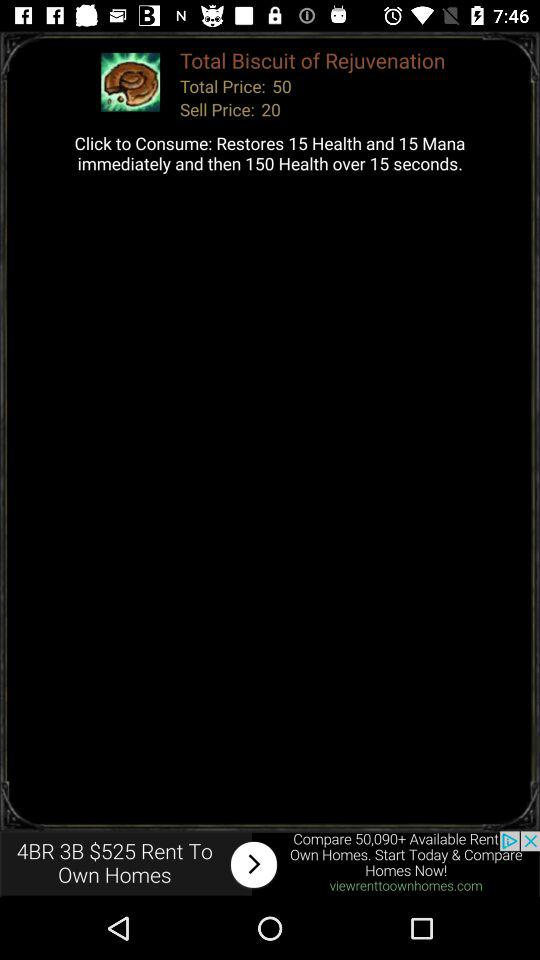How much health does the item restore immediately?
Answer the question using a single word or phrase. 15 